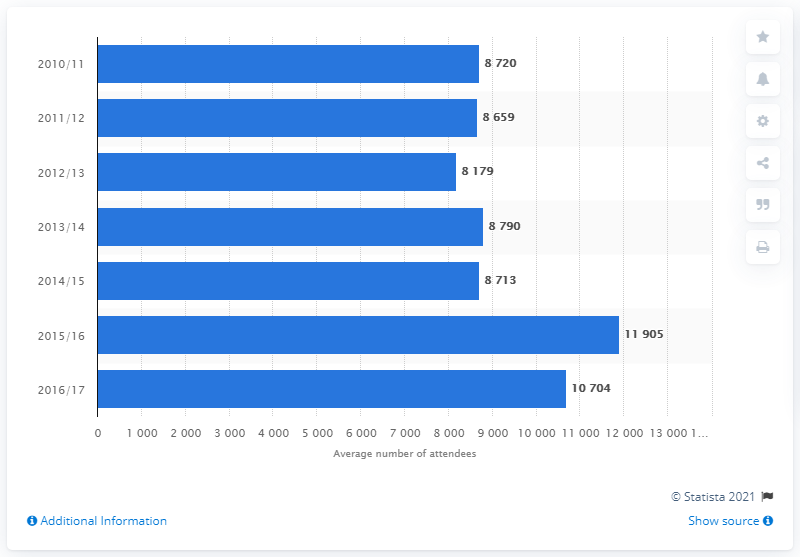Point out several critical features in this image. In 2017, the average number of people who attended matches of the Jupiler Pro League was 10,704. 